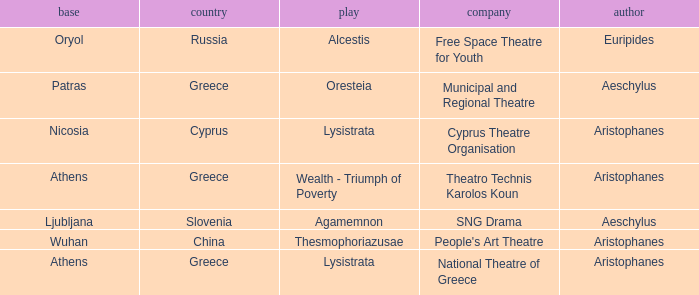What is the play when the company is national theatre of greece? Lysistrata. 